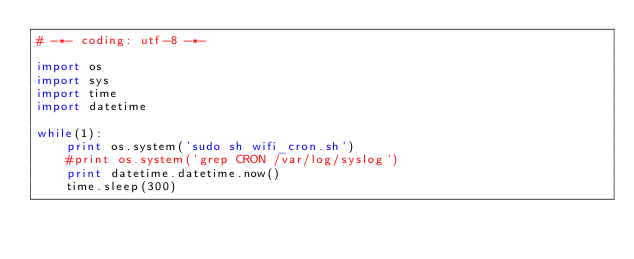<code> <loc_0><loc_0><loc_500><loc_500><_Python_># -*- coding: utf-8 -*-

import os
import sys
import time
import datetime

while(1):
    print os.system('sudo sh wifi_cron.sh')
    #print os.system('grep CRON /var/log/syslog')
    print datetime.datetime.now()   
    time.sleep(300)
</code> 